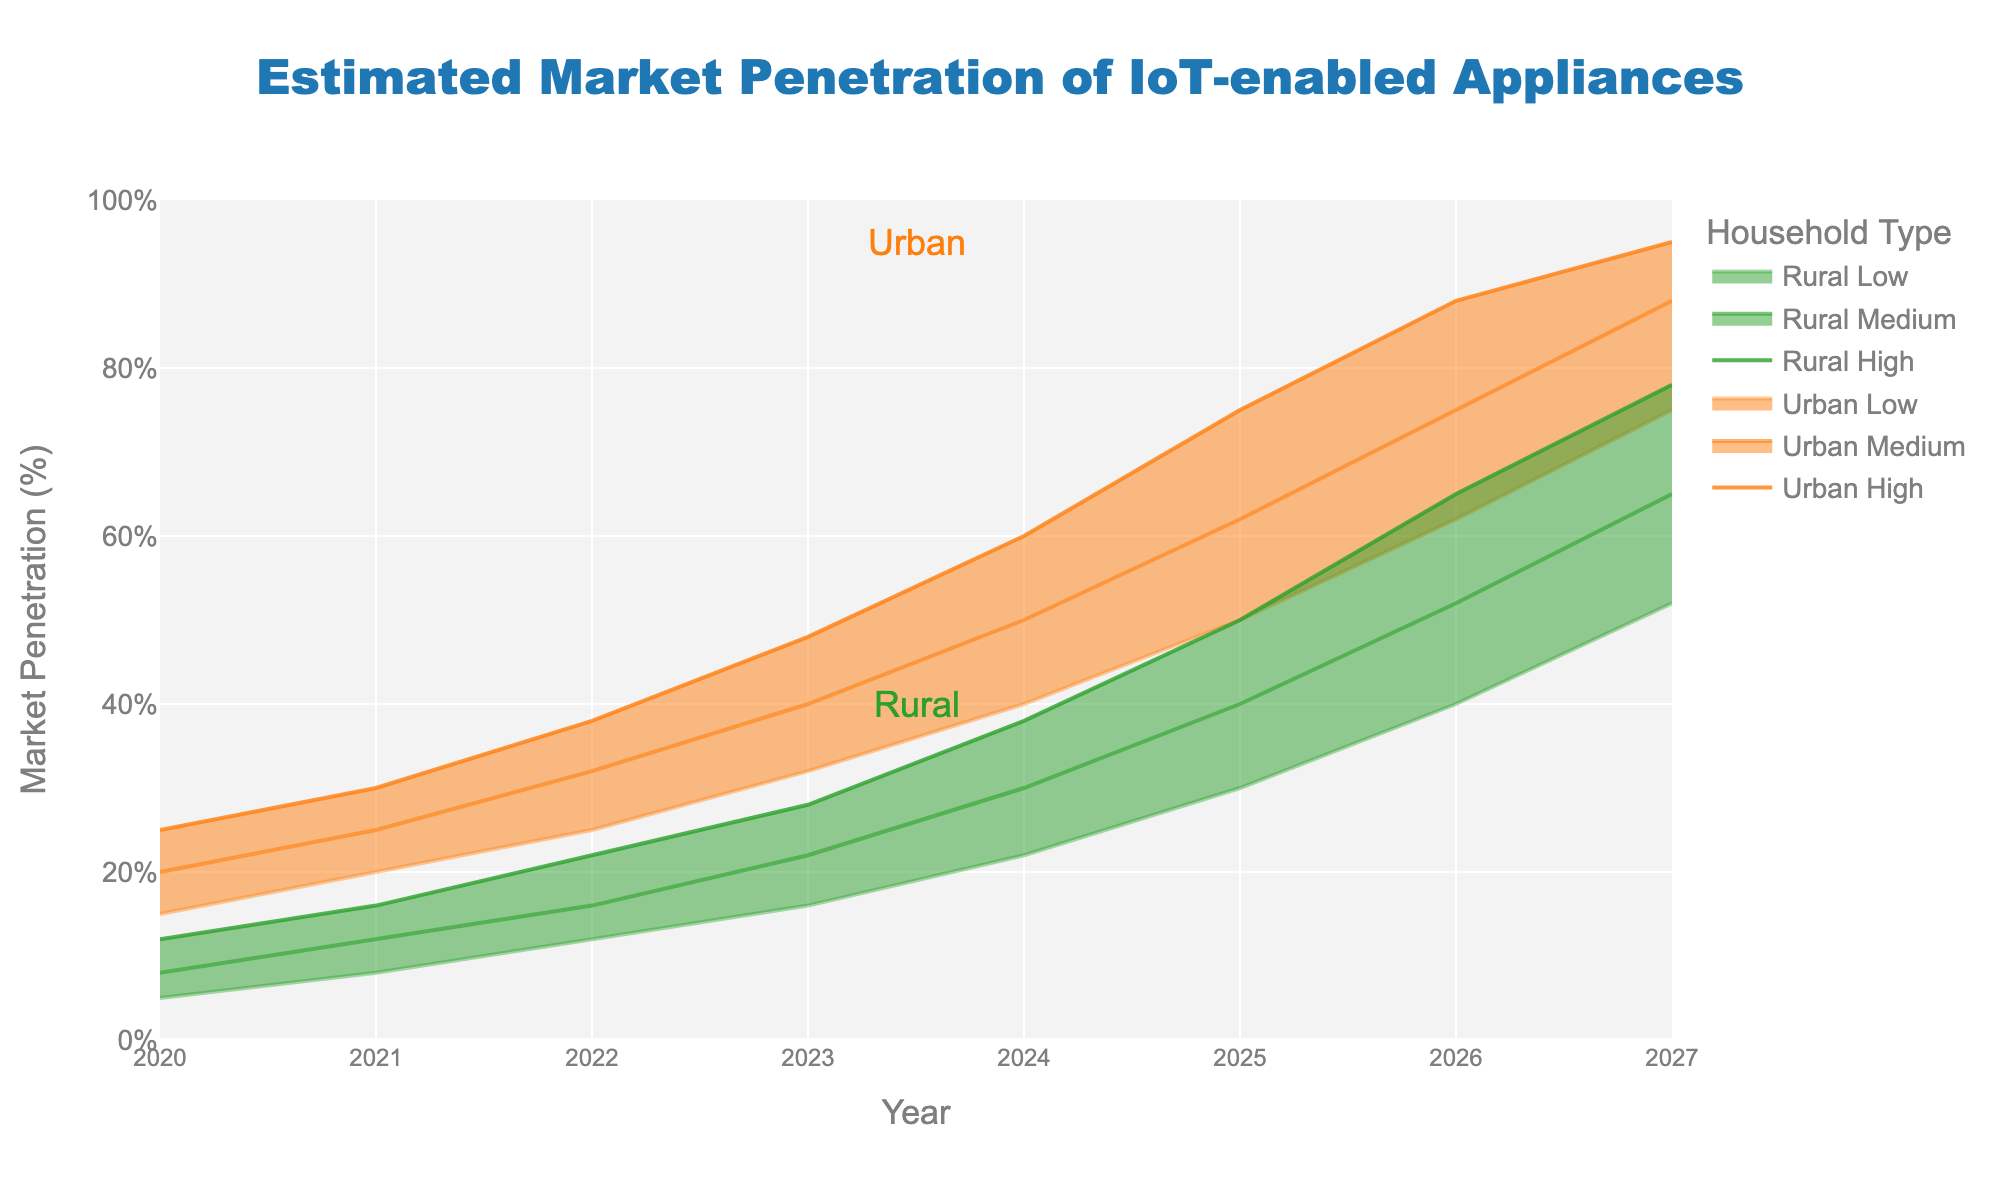What is the title of the chart? The title is located at the top center of the chart. It reads "Estimated Market Penetration of IoT-enabled Appliances".
Answer: Estimated Market Penetration of IoT-enabled Appliances What are the two household types shown on the chart? The two household types are indicated by the annotations and legend. The chart includes "Urban" and "Rural" households.
Answer: Urban and Rural What is the market penetration range for urban households in 2023? For the year 2023, the urban market penetration ranges from the low to high estimates indicated by the respective lines. It ranges from 32% (Low) to 48% (High).
Answer: 32% to 48% How has the rural medium estimate changed from 2022 to 2024? In 2022, the rural medium estimate is 16%, and in 2024, it is 30%. The change is calculated by subtracting the 2022 figure from the 2024 figure (30% - 16% = 14%).
Answer: 14% increase Which year has the highest market penetration estimate for urban high? The highest estimate for urban high is observed at the last data point of the chart, which is the year 2027 at 95%.
Answer: 2027 What is the difference between the urban and rural high estimates in 2026? For 2026, the high estimate for urban is 88%, and for rural, it is 65%. The difference between them is calculated by subtracting the rural high from the urban high (88% - 65% = 23%).
Answer: 23% How many years of data are displayed on the chart? The x-axis labeled "Year" displays data from 2020 to 2027. Counting these years includes both 2020 and 2027, giving a total of 8 years.
Answer: 8 years Which household type shows a higher increase in its medium estimate from 2020 to 2027? For urban households, the medium estimate increases from 20% in 2020 to 88% in 2027 (an increase of 68%). For rural households, it increases from 8% in 2020 to 65% in 2027 (an increase of 57%). Thus, urban households show a higher increase.
Answer: Urban What is the average of the rural low estimates from 2023 to 2025? The rural low estimates for 2023, 2024, and 2025 are 16%, 22%, and 30% respectively. Calculating the average: (16% + 22% + 30%) / 3 = 68% / 3 ≈ 22.7%
Answer: 22.7% What is the trend in market penetration for urban households from 2020 to 2027? The trend can be observed by following the increasing values of urban low, medium, and high estimates over the years. Each of these estimates shows a consistent upward trajectory indicating growth in market penetration.
Answer: Increasing trend 